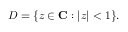<formula> <loc_0><loc_0><loc_500><loc_500>D = \{ z \in C \colon | z | < 1 \} .</formula> 